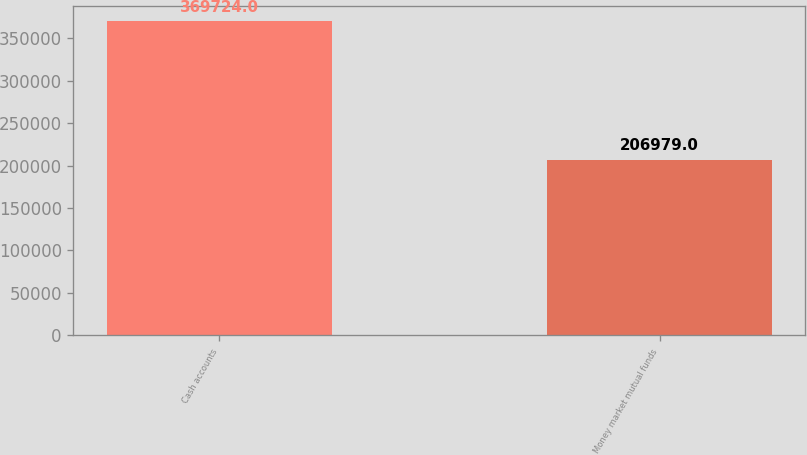Convert chart. <chart><loc_0><loc_0><loc_500><loc_500><bar_chart><fcel>Cash accounts<fcel>Money market mutual funds<nl><fcel>369724<fcel>206979<nl></chart> 